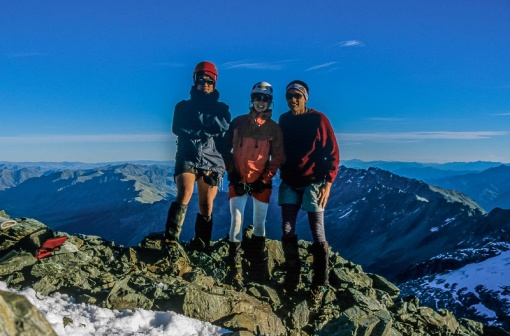Describe a possible backstory for the adventurer in the blue jacket. The adventurer in the blue jacket, let’s call them Alex, could be an experienced mountaineer with a passion for exploring new heights. Having grown up near mountainous regions, Alex has always been fascinated by the challenge and beauty of high-altitude landscapes. This particular journey marks a significant chapter in their life, as they set out to conquer one of the highest peaks in the region to honor a close friend who shared their love of the mountains but passed away the previous year. The red pants symbolize the spirit and memory of their friend, driving Alex forward even through the toughest parts of the climb. Do you think this group had any specific rituals or traditions for their climbs? It’s quite possible that this group of friends has a few rituals or traditions for their climbs. For instance, they might have a pre-climb ritual where they spend a few moments in silent meditation, focusing on the journey ahead and mentally preparing themselves for the challenges. Perhaps they also carry a small token or memento, such as a lucky charm or a photo of a loved one, which they bring to every summit. Upon reaching the peak, they might celebrate by taking a group photo in the sharegpt4v/same poses or with a specific gesture, signifying their unity and the bond they share. These traditions not only help them stay motivated but also create lasting memories and a sense of continuity in their adventures. 